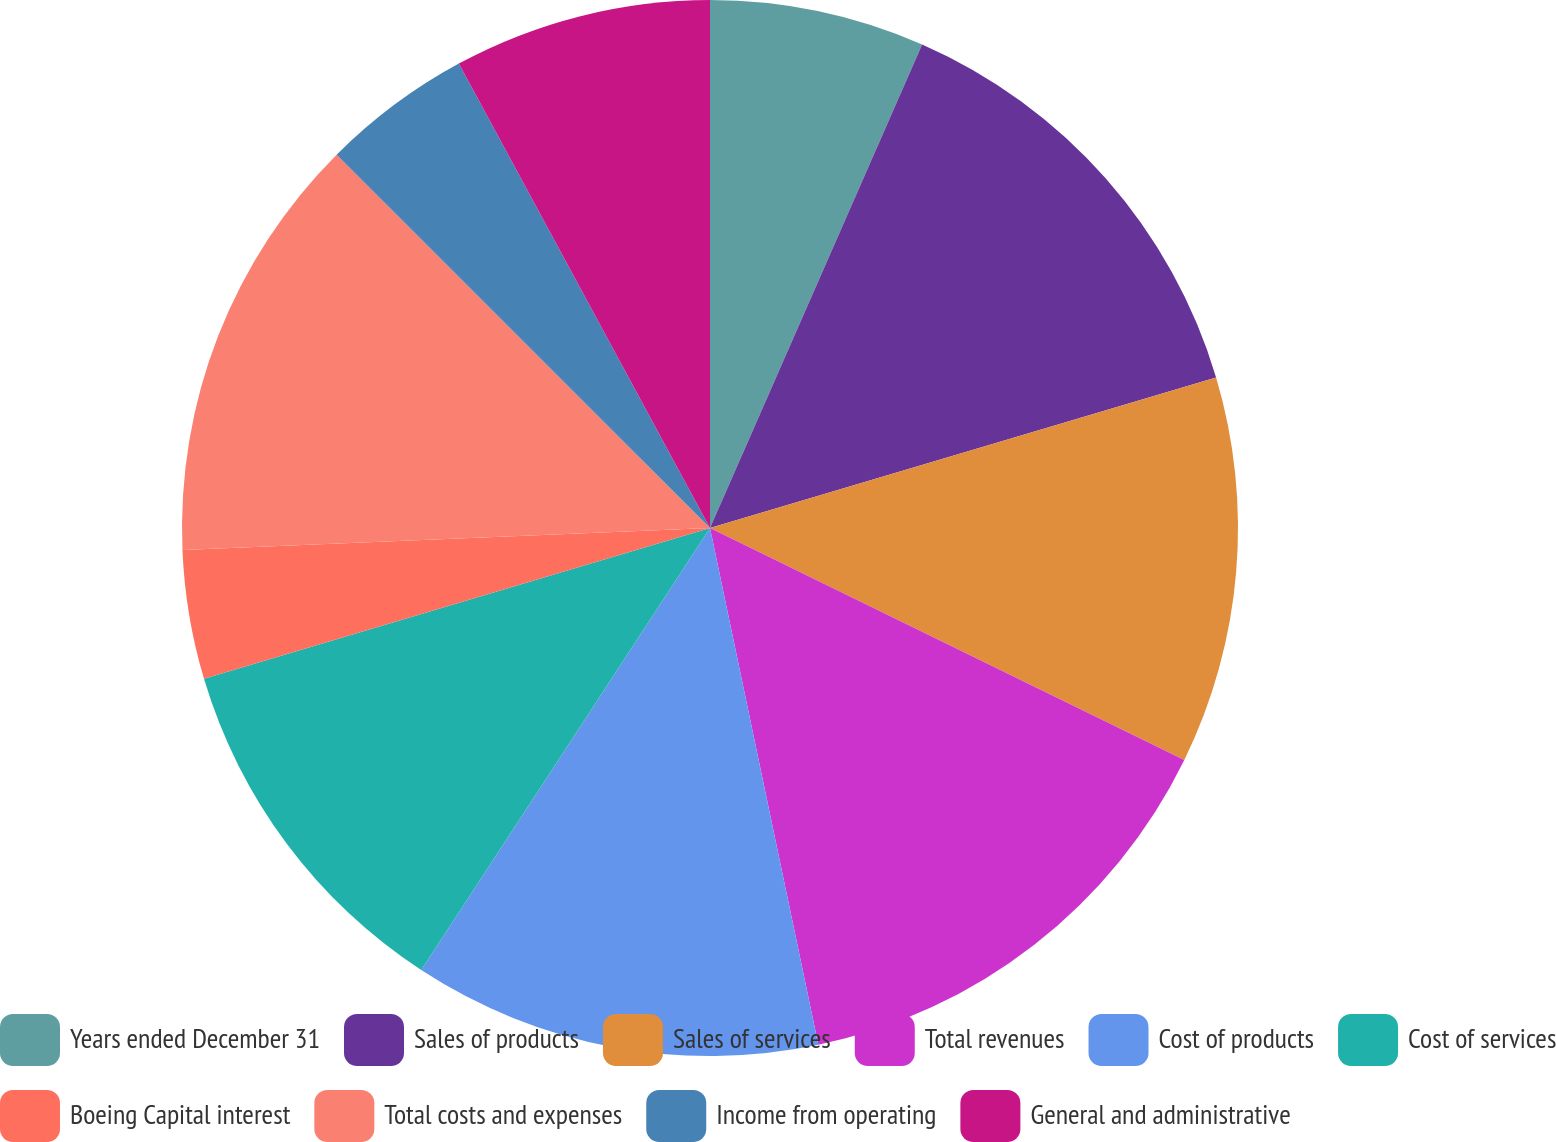<chart> <loc_0><loc_0><loc_500><loc_500><pie_chart><fcel>Years ended December 31<fcel>Sales of products<fcel>Sales of services<fcel>Total revenues<fcel>Cost of products<fcel>Cost of services<fcel>Boeing Capital interest<fcel>Total costs and expenses<fcel>Income from operating<fcel>General and administrative<nl><fcel>6.58%<fcel>13.82%<fcel>11.84%<fcel>14.47%<fcel>12.5%<fcel>11.18%<fcel>3.95%<fcel>13.16%<fcel>4.61%<fcel>7.89%<nl></chart> 